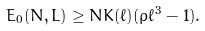<formula> <loc_0><loc_0><loc_500><loc_500>E _ { 0 } ( N , L ) \geq N K ( \ell ) ( \rho \ell ^ { 3 } - 1 ) .</formula> 